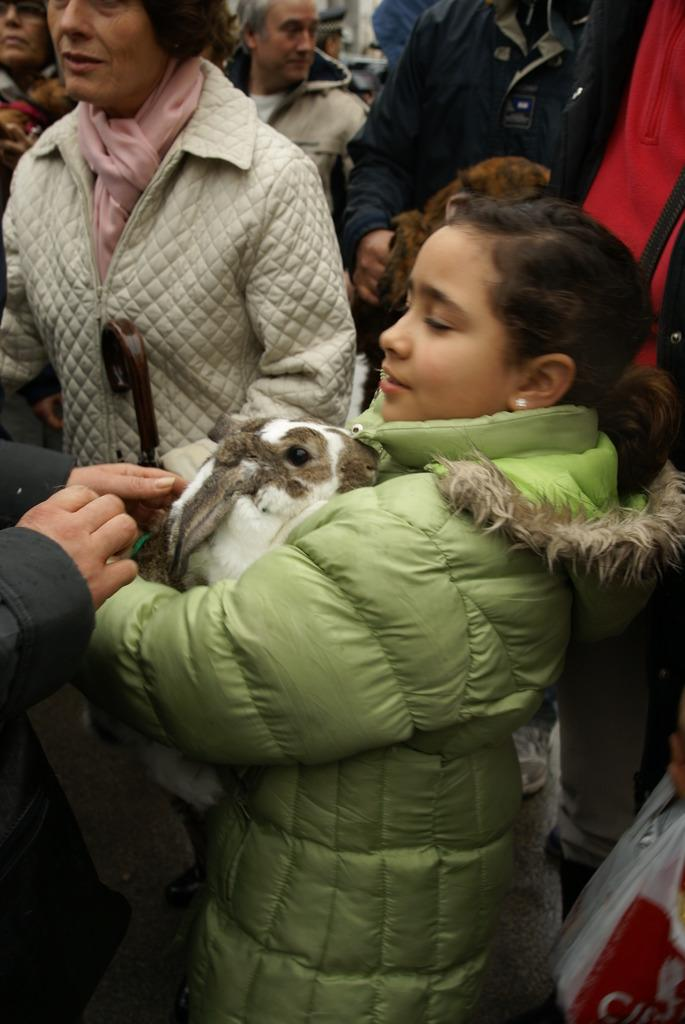What is happening in the image? There are people standing in the image. Where are the people standing? The people are standing on the floor. What are some of the people doing with their hands? Some of the people are holding animals in their hands. What type of brass instrument is being played by the people in the image? There is no brass instrument present in the image; the people are holding animals in their hands. 